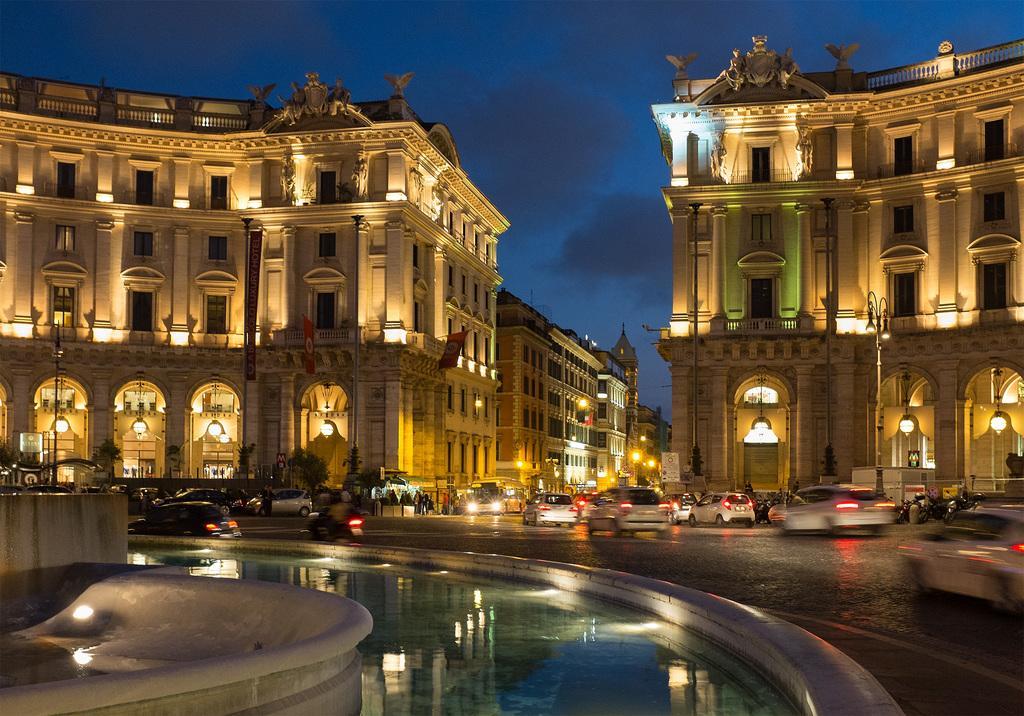Describe this image in one or two sentences. In this image few vehicles are on the road. Few persons are on the pavement and few persons are on the road. Bottom of image there is water beside the wall. There are few trees, behind there are few buildings. Top of image there is sky. 